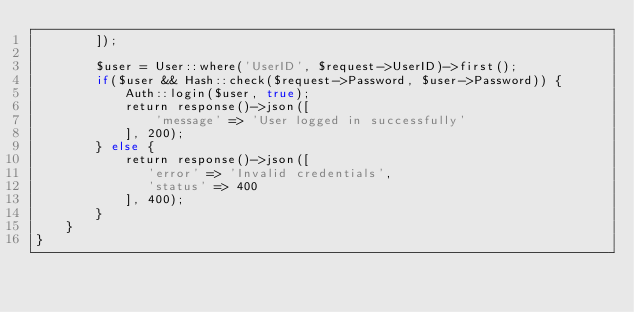<code> <loc_0><loc_0><loc_500><loc_500><_PHP_>        ]);

        $user = User::where('UserID', $request->UserID)->first();
        if($user && Hash::check($request->Password, $user->Password)) {
            Auth::login($user, true);
            return response()->json([
                'message' => 'User logged in successfully'
            ], 200);
        } else {
            return response()->json([
               'error' => 'Invalid credentials',
               'status' => 400
            ], 400);
        }
    }
}
</code> 